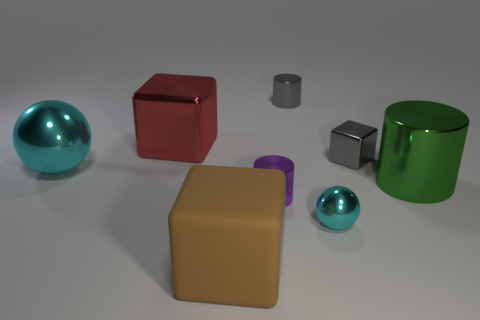What might be the context or setting this image represents? This image seems to represent a simple 3D rendering likely created to demonstrate various geometric shapes and reflections. The uniform background and lighting suggest it might be used for educational purposes or as a visual aid in a graphics-related field. 